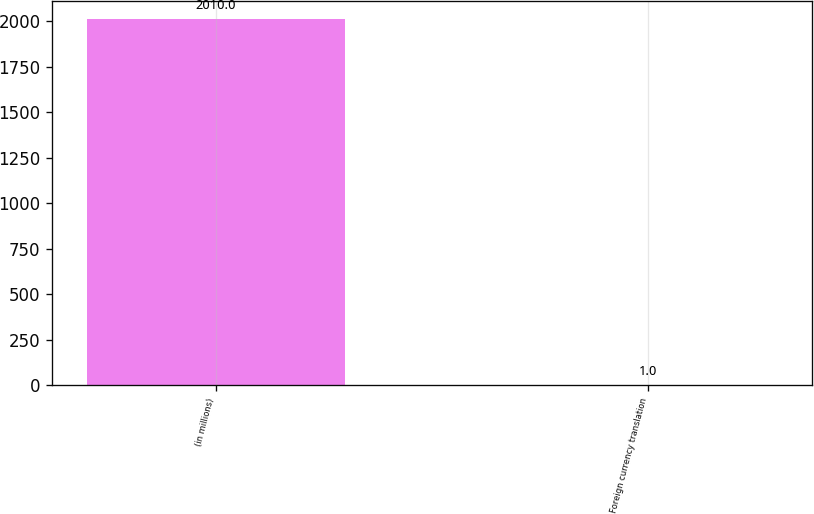<chart> <loc_0><loc_0><loc_500><loc_500><bar_chart><fcel>(in millions)<fcel>Foreign currency translation<nl><fcel>2010<fcel>1<nl></chart> 